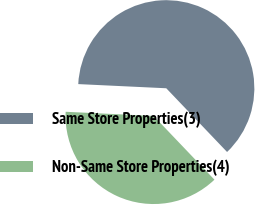Convert chart to OTSL. <chart><loc_0><loc_0><loc_500><loc_500><pie_chart><fcel>Same Store Properties(3)<fcel>Non-Same Store Properties(4)<nl><fcel>62.12%<fcel>37.88%<nl></chart> 